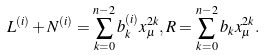<formula> <loc_0><loc_0><loc_500><loc_500>L ^ { ( i ) } + N ^ { ( i ) } = \sum _ { k = 0 } ^ { n - 2 } b _ { k } ^ { ( i ) } x _ { \mu } ^ { 2 k } , R = \sum _ { k = 0 } ^ { n - 2 } b _ { k } x _ { \mu } ^ { 2 k } .</formula> 